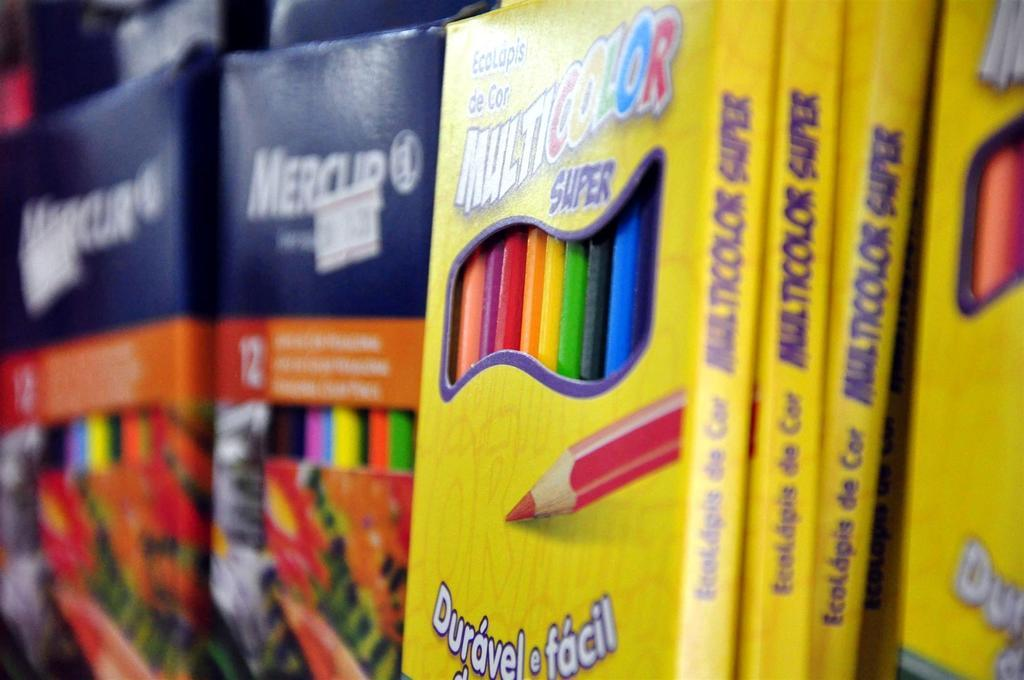Provide a one-sentence caption for the provided image. A close up of packs of childrens mutlicolored pencils. 